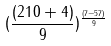Convert formula to latex. <formula><loc_0><loc_0><loc_500><loc_500>( \frac { ( 2 1 0 + 4 ) } { 9 } ) ^ { \frac { ( 7 - 5 7 ) } { 9 } }</formula> 